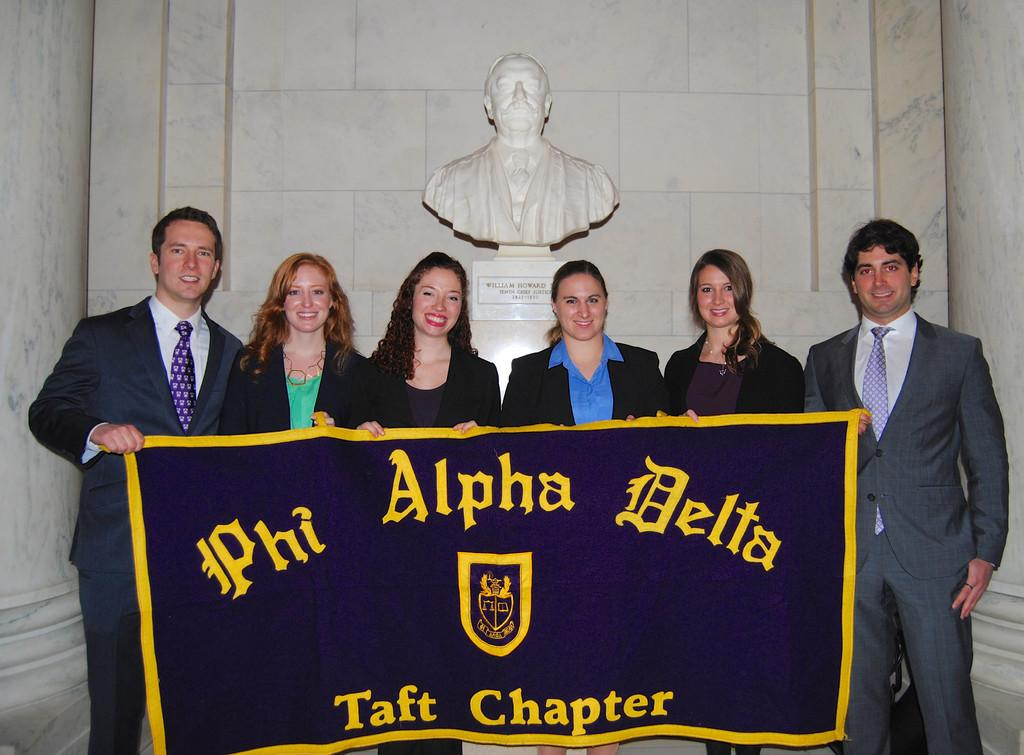What are the people in the image doing? The people in the image are standing in the center and holding a banner. What can be seen in the background of the image? There is a statue and a wall in the background of the image. How does the expert balance the mist in the image? There is no expert or mist present in the image. The image features people holding a banner, a statue, and a wall in the background. 